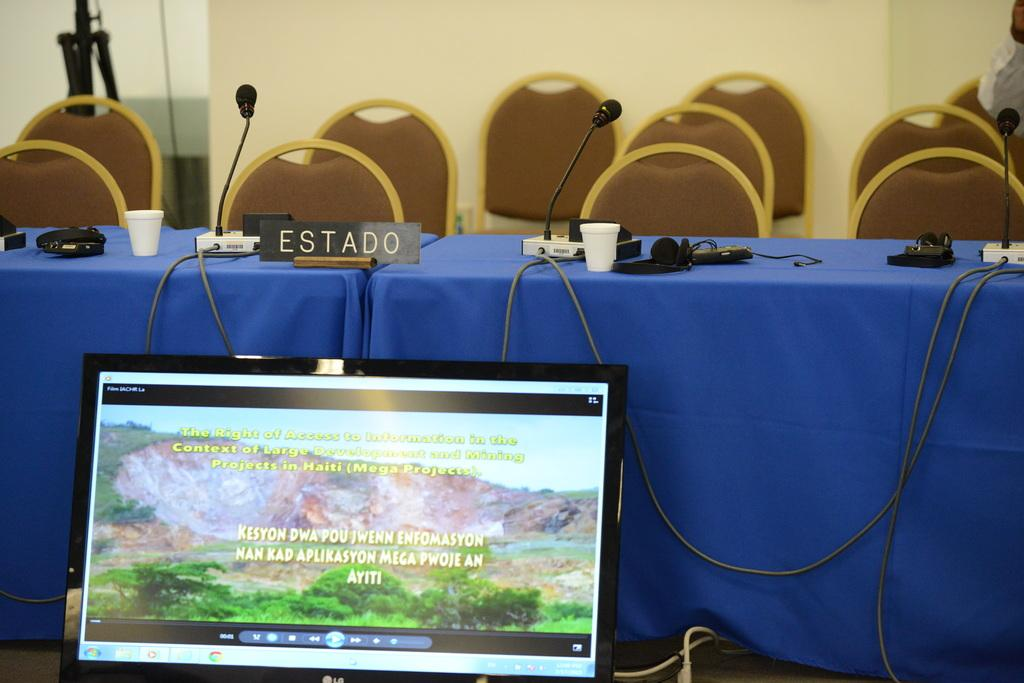<image>
Provide a brief description of the given image. A black placard on the table reads Estado. 